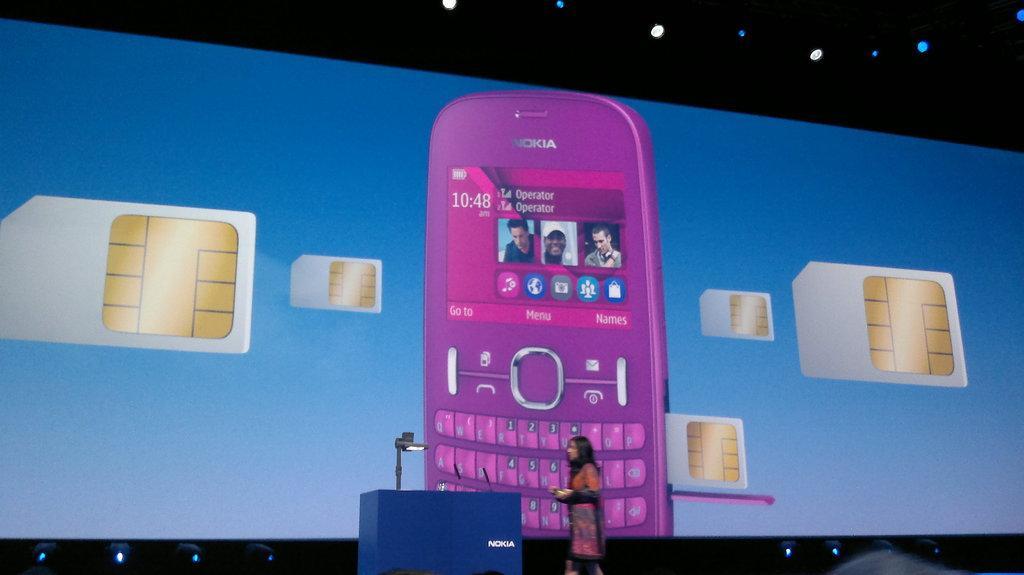How would you summarize this image in a sentence or two? In this picture we can see a woman is standing on the stage. On the left side of the woman, it looks like a podium. Behind the woman there is a screen and on the screen there is a mobile and "SIM cards". At the top and bottom of the screen there are lights. 